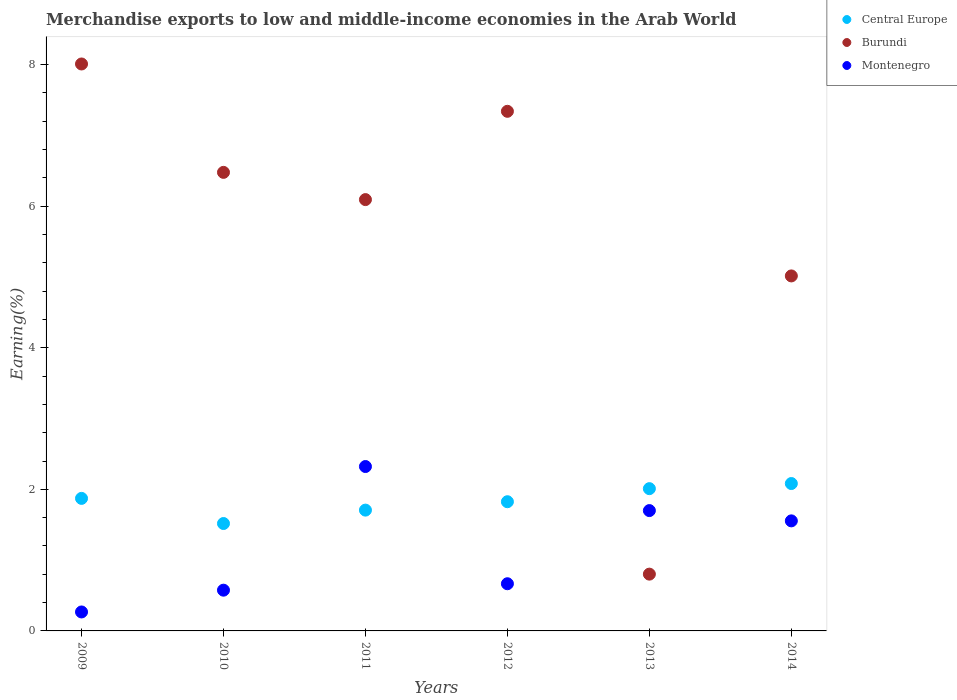How many different coloured dotlines are there?
Provide a succinct answer. 3. Is the number of dotlines equal to the number of legend labels?
Offer a very short reply. Yes. What is the percentage of amount earned from merchandise exports in Central Europe in 2014?
Offer a terse response. 2.08. Across all years, what is the maximum percentage of amount earned from merchandise exports in Central Europe?
Your answer should be very brief. 2.08. Across all years, what is the minimum percentage of amount earned from merchandise exports in Central Europe?
Provide a succinct answer. 1.52. What is the total percentage of amount earned from merchandise exports in Central Europe in the graph?
Give a very brief answer. 11.01. What is the difference between the percentage of amount earned from merchandise exports in Central Europe in 2010 and that in 2011?
Your answer should be very brief. -0.19. What is the difference between the percentage of amount earned from merchandise exports in Burundi in 2014 and the percentage of amount earned from merchandise exports in Central Europe in 2010?
Make the answer very short. 3.5. What is the average percentage of amount earned from merchandise exports in Central Europe per year?
Your answer should be very brief. 1.84. In the year 2014, what is the difference between the percentage of amount earned from merchandise exports in Burundi and percentage of amount earned from merchandise exports in Central Europe?
Your response must be concise. 2.93. In how many years, is the percentage of amount earned from merchandise exports in Central Europe greater than 4 %?
Offer a terse response. 0. What is the ratio of the percentage of amount earned from merchandise exports in Burundi in 2010 to that in 2014?
Offer a very short reply. 1.29. Is the difference between the percentage of amount earned from merchandise exports in Burundi in 2012 and 2014 greater than the difference between the percentage of amount earned from merchandise exports in Central Europe in 2012 and 2014?
Provide a succinct answer. Yes. What is the difference between the highest and the second highest percentage of amount earned from merchandise exports in Central Europe?
Your answer should be very brief. 0.07. What is the difference between the highest and the lowest percentage of amount earned from merchandise exports in Montenegro?
Provide a succinct answer. 2.05. Is the sum of the percentage of amount earned from merchandise exports in Burundi in 2009 and 2012 greater than the maximum percentage of amount earned from merchandise exports in Central Europe across all years?
Offer a very short reply. Yes. Is the percentage of amount earned from merchandise exports in Burundi strictly less than the percentage of amount earned from merchandise exports in Montenegro over the years?
Your answer should be very brief. No. How many dotlines are there?
Give a very brief answer. 3. How many years are there in the graph?
Make the answer very short. 6. Are the values on the major ticks of Y-axis written in scientific E-notation?
Offer a terse response. No. Does the graph contain any zero values?
Provide a succinct answer. No. Where does the legend appear in the graph?
Give a very brief answer. Top right. What is the title of the graph?
Your answer should be very brief. Merchandise exports to low and middle-income economies in the Arab World. What is the label or title of the Y-axis?
Provide a succinct answer. Earning(%). What is the Earning(%) in Central Europe in 2009?
Your answer should be compact. 1.87. What is the Earning(%) in Burundi in 2009?
Make the answer very short. 8.01. What is the Earning(%) of Montenegro in 2009?
Give a very brief answer. 0.27. What is the Earning(%) in Central Europe in 2010?
Your answer should be compact. 1.52. What is the Earning(%) of Burundi in 2010?
Provide a succinct answer. 6.48. What is the Earning(%) of Montenegro in 2010?
Ensure brevity in your answer.  0.58. What is the Earning(%) of Central Europe in 2011?
Offer a very short reply. 1.71. What is the Earning(%) of Burundi in 2011?
Give a very brief answer. 6.09. What is the Earning(%) of Montenegro in 2011?
Your answer should be compact. 2.32. What is the Earning(%) in Central Europe in 2012?
Offer a very short reply. 1.83. What is the Earning(%) of Burundi in 2012?
Provide a succinct answer. 7.34. What is the Earning(%) in Montenegro in 2012?
Ensure brevity in your answer.  0.67. What is the Earning(%) of Central Europe in 2013?
Your answer should be very brief. 2.01. What is the Earning(%) in Burundi in 2013?
Keep it short and to the point. 0.8. What is the Earning(%) in Montenegro in 2013?
Make the answer very short. 1.7. What is the Earning(%) of Central Europe in 2014?
Make the answer very short. 2.08. What is the Earning(%) of Burundi in 2014?
Ensure brevity in your answer.  5.02. What is the Earning(%) of Montenegro in 2014?
Make the answer very short. 1.55. Across all years, what is the maximum Earning(%) in Central Europe?
Your answer should be compact. 2.08. Across all years, what is the maximum Earning(%) in Burundi?
Offer a terse response. 8.01. Across all years, what is the maximum Earning(%) in Montenegro?
Your answer should be very brief. 2.32. Across all years, what is the minimum Earning(%) of Central Europe?
Provide a succinct answer. 1.52. Across all years, what is the minimum Earning(%) in Burundi?
Offer a very short reply. 0.8. Across all years, what is the minimum Earning(%) of Montenegro?
Provide a short and direct response. 0.27. What is the total Earning(%) of Central Europe in the graph?
Provide a short and direct response. 11.01. What is the total Earning(%) in Burundi in the graph?
Your response must be concise. 33.74. What is the total Earning(%) of Montenegro in the graph?
Provide a succinct answer. 7.09. What is the difference between the Earning(%) of Central Europe in 2009 and that in 2010?
Provide a succinct answer. 0.36. What is the difference between the Earning(%) of Burundi in 2009 and that in 2010?
Provide a succinct answer. 1.53. What is the difference between the Earning(%) in Montenegro in 2009 and that in 2010?
Offer a terse response. -0.31. What is the difference between the Earning(%) of Central Europe in 2009 and that in 2011?
Provide a succinct answer. 0.17. What is the difference between the Earning(%) in Burundi in 2009 and that in 2011?
Provide a succinct answer. 1.92. What is the difference between the Earning(%) of Montenegro in 2009 and that in 2011?
Provide a succinct answer. -2.05. What is the difference between the Earning(%) of Central Europe in 2009 and that in 2012?
Offer a very short reply. 0.05. What is the difference between the Earning(%) of Burundi in 2009 and that in 2012?
Your response must be concise. 0.67. What is the difference between the Earning(%) of Montenegro in 2009 and that in 2012?
Your answer should be very brief. -0.4. What is the difference between the Earning(%) in Central Europe in 2009 and that in 2013?
Offer a terse response. -0.14. What is the difference between the Earning(%) in Burundi in 2009 and that in 2013?
Your answer should be compact. 7.21. What is the difference between the Earning(%) in Montenegro in 2009 and that in 2013?
Offer a terse response. -1.43. What is the difference between the Earning(%) in Central Europe in 2009 and that in 2014?
Offer a very short reply. -0.21. What is the difference between the Earning(%) in Burundi in 2009 and that in 2014?
Offer a terse response. 2.99. What is the difference between the Earning(%) in Montenegro in 2009 and that in 2014?
Provide a short and direct response. -1.29. What is the difference between the Earning(%) of Central Europe in 2010 and that in 2011?
Your answer should be compact. -0.19. What is the difference between the Earning(%) of Burundi in 2010 and that in 2011?
Your answer should be compact. 0.38. What is the difference between the Earning(%) of Montenegro in 2010 and that in 2011?
Give a very brief answer. -1.75. What is the difference between the Earning(%) of Central Europe in 2010 and that in 2012?
Give a very brief answer. -0.31. What is the difference between the Earning(%) of Burundi in 2010 and that in 2012?
Offer a terse response. -0.86. What is the difference between the Earning(%) in Montenegro in 2010 and that in 2012?
Your response must be concise. -0.09. What is the difference between the Earning(%) in Central Europe in 2010 and that in 2013?
Make the answer very short. -0.49. What is the difference between the Earning(%) of Burundi in 2010 and that in 2013?
Your answer should be compact. 5.68. What is the difference between the Earning(%) in Montenegro in 2010 and that in 2013?
Offer a very short reply. -1.12. What is the difference between the Earning(%) of Central Europe in 2010 and that in 2014?
Make the answer very short. -0.56. What is the difference between the Earning(%) in Burundi in 2010 and that in 2014?
Provide a short and direct response. 1.46. What is the difference between the Earning(%) of Montenegro in 2010 and that in 2014?
Offer a very short reply. -0.98. What is the difference between the Earning(%) of Central Europe in 2011 and that in 2012?
Make the answer very short. -0.12. What is the difference between the Earning(%) in Burundi in 2011 and that in 2012?
Offer a terse response. -1.25. What is the difference between the Earning(%) in Montenegro in 2011 and that in 2012?
Your answer should be compact. 1.66. What is the difference between the Earning(%) of Central Europe in 2011 and that in 2013?
Make the answer very short. -0.3. What is the difference between the Earning(%) of Burundi in 2011 and that in 2013?
Ensure brevity in your answer.  5.29. What is the difference between the Earning(%) of Montenegro in 2011 and that in 2013?
Make the answer very short. 0.62. What is the difference between the Earning(%) in Central Europe in 2011 and that in 2014?
Offer a terse response. -0.38. What is the difference between the Earning(%) of Burundi in 2011 and that in 2014?
Offer a very short reply. 1.08. What is the difference between the Earning(%) of Montenegro in 2011 and that in 2014?
Keep it short and to the point. 0.77. What is the difference between the Earning(%) of Central Europe in 2012 and that in 2013?
Your answer should be compact. -0.18. What is the difference between the Earning(%) of Burundi in 2012 and that in 2013?
Offer a very short reply. 6.54. What is the difference between the Earning(%) of Montenegro in 2012 and that in 2013?
Offer a very short reply. -1.03. What is the difference between the Earning(%) of Central Europe in 2012 and that in 2014?
Give a very brief answer. -0.26. What is the difference between the Earning(%) in Burundi in 2012 and that in 2014?
Your answer should be compact. 2.33. What is the difference between the Earning(%) in Montenegro in 2012 and that in 2014?
Keep it short and to the point. -0.89. What is the difference between the Earning(%) of Central Europe in 2013 and that in 2014?
Provide a succinct answer. -0.07. What is the difference between the Earning(%) of Burundi in 2013 and that in 2014?
Your answer should be compact. -4.21. What is the difference between the Earning(%) of Montenegro in 2013 and that in 2014?
Provide a succinct answer. 0.15. What is the difference between the Earning(%) of Central Europe in 2009 and the Earning(%) of Burundi in 2010?
Your response must be concise. -4.61. What is the difference between the Earning(%) in Central Europe in 2009 and the Earning(%) in Montenegro in 2010?
Offer a very short reply. 1.3. What is the difference between the Earning(%) in Burundi in 2009 and the Earning(%) in Montenegro in 2010?
Ensure brevity in your answer.  7.43. What is the difference between the Earning(%) of Central Europe in 2009 and the Earning(%) of Burundi in 2011?
Ensure brevity in your answer.  -4.22. What is the difference between the Earning(%) in Central Europe in 2009 and the Earning(%) in Montenegro in 2011?
Provide a succinct answer. -0.45. What is the difference between the Earning(%) of Burundi in 2009 and the Earning(%) of Montenegro in 2011?
Your answer should be compact. 5.69. What is the difference between the Earning(%) in Central Europe in 2009 and the Earning(%) in Burundi in 2012?
Provide a short and direct response. -5.47. What is the difference between the Earning(%) in Central Europe in 2009 and the Earning(%) in Montenegro in 2012?
Your answer should be compact. 1.21. What is the difference between the Earning(%) of Burundi in 2009 and the Earning(%) of Montenegro in 2012?
Ensure brevity in your answer.  7.34. What is the difference between the Earning(%) in Central Europe in 2009 and the Earning(%) in Burundi in 2013?
Ensure brevity in your answer.  1.07. What is the difference between the Earning(%) in Central Europe in 2009 and the Earning(%) in Montenegro in 2013?
Keep it short and to the point. 0.17. What is the difference between the Earning(%) in Burundi in 2009 and the Earning(%) in Montenegro in 2013?
Keep it short and to the point. 6.31. What is the difference between the Earning(%) of Central Europe in 2009 and the Earning(%) of Burundi in 2014?
Make the answer very short. -3.14. What is the difference between the Earning(%) in Central Europe in 2009 and the Earning(%) in Montenegro in 2014?
Provide a succinct answer. 0.32. What is the difference between the Earning(%) in Burundi in 2009 and the Earning(%) in Montenegro in 2014?
Your answer should be compact. 6.45. What is the difference between the Earning(%) in Central Europe in 2010 and the Earning(%) in Burundi in 2011?
Make the answer very short. -4.58. What is the difference between the Earning(%) of Central Europe in 2010 and the Earning(%) of Montenegro in 2011?
Your response must be concise. -0.81. What is the difference between the Earning(%) in Burundi in 2010 and the Earning(%) in Montenegro in 2011?
Offer a very short reply. 4.16. What is the difference between the Earning(%) of Central Europe in 2010 and the Earning(%) of Burundi in 2012?
Your answer should be very brief. -5.82. What is the difference between the Earning(%) of Central Europe in 2010 and the Earning(%) of Montenegro in 2012?
Your answer should be very brief. 0.85. What is the difference between the Earning(%) in Burundi in 2010 and the Earning(%) in Montenegro in 2012?
Keep it short and to the point. 5.81. What is the difference between the Earning(%) in Central Europe in 2010 and the Earning(%) in Burundi in 2013?
Keep it short and to the point. 0.72. What is the difference between the Earning(%) of Central Europe in 2010 and the Earning(%) of Montenegro in 2013?
Ensure brevity in your answer.  -0.18. What is the difference between the Earning(%) in Burundi in 2010 and the Earning(%) in Montenegro in 2013?
Provide a succinct answer. 4.78. What is the difference between the Earning(%) of Central Europe in 2010 and the Earning(%) of Burundi in 2014?
Your answer should be compact. -3.5. What is the difference between the Earning(%) in Central Europe in 2010 and the Earning(%) in Montenegro in 2014?
Your response must be concise. -0.04. What is the difference between the Earning(%) in Burundi in 2010 and the Earning(%) in Montenegro in 2014?
Offer a very short reply. 4.92. What is the difference between the Earning(%) of Central Europe in 2011 and the Earning(%) of Burundi in 2012?
Offer a terse response. -5.63. What is the difference between the Earning(%) of Burundi in 2011 and the Earning(%) of Montenegro in 2012?
Offer a terse response. 5.43. What is the difference between the Earning(%) in Central Europe in 2011 and the Earning(%) in Burundi in 2013?
Offer a very short reply. 0.9. What is the difference between the Earning(%) of Central Europe in 2011 and the Earning(%) of Montenegro in 2013?
Offer a very short reply. 0.01. What is the difference between the Earning(%) in Burundi in 2011 and the Earning(%) in Montenegro in 2013?
Offer a very short reply. 4.39. What is the difference between the Earning(%) in Central Europe in 2011 and the Earning(%) in Burundi in 2014?
Ensure brevity in your answer.  -3.31. What is the difference between the Earning(%) in Central Europe in 2011 and the Earning(%) in Montenegro in 2014?
Make the answer very short. 0.15. What is the difference between the Earning(%) of Burundi in 2011 and the Earning(%) of Montenegro in 2014?
Your answer should be compact. 4.54. What is the difference between the Earning(%) of Central Europe in 2012 and the Earning(%) of Burundi in 2013?
Your answer should be compact. 1.02. What is the difference between the Earning(%) of Central Europe in 2012 and the Earning(%) of Montenegro in 2013?
Give a very brief answer. 0.13. What is the difference between the Earning(%) in Burundi in 2012 and the Earning(%) in Montenegro in 2013?
Ensure brevity in your answer.  5.64. What is the difference between the Earning(%) in Central Europe in 2012 and the Earning(%) in Burundi in 2014?
Offer a terse response. -3.19. What is the difference between the Earning(%) of Central Europe in 2012 and the Earning(%) of Montenegro in 2014?
Your answer should be very brief. 0.27. What is the difference between the Earning(%) of Burundi in 2012 and the Earning(%) of Montenegro in 2014?
Ensure brevity in your answer.  5.79. What is the difference between the Earning(%) in Central Europe in 2013 and the Earning(%) in Burundi in 2014?
Your answer should be compact. -3.01. What is the difference between the Earning(%) in Central Europe in 2013 and the Earning(%) in Montenegro in 2014?
Offer a very short reply. 0.46. What is the difference between the Earning(%) in Burundi in 2013 and the Earning(%) in Montenegro in 2014?
Provide a succinct answer. -0.75. What is the average Earning(%) in Central Europe per year?
Keep it short and to the point. 1.84. What is the average Earning(%) of Burundi per year?
Provide a short and direct response. 5.62. What is the average Earning(%) of Montenegro per year?
Your answer should be compact. 1.18. In the year 2009, what is the difference between the Earning(%) of Central Europe and Earning(%) of Burundi?
Keep it short and to the point. -6.14. In the year 2009, what is the difference between the Earning(%) of Central Europe and Earning(%) of Montenegro?
Your response must be concise. 1.6. In the year 2009, what is the difference between the Earning(%) in Burundi and Earning(%) in Montenegro?
Your response must be concise. 7.74. In the year 2010, what is the difference between the Earning(%) of Central Europe and Earning(%) of Burundi?
Offer a very short reply. -4.96. In the year 2010, what is the difference between the Earning(%) of Central Europe and Earning(%) of Montenegro?
Give a very brief answer. 0.94. In the year 2010, what is the difference between the Earning(%) in Burundi and Earning(%) in Montenegro?
Your response must be concise. 5.9. In the year 2011, what is the difference between the Earning(%) of Central Europe and Earning(%) of Burundi?
Offer a terse response. -4.39. In the year 2011, what is the difference between the Earning(%) of Central Europe and Earning(%) of Montenegro?
Your answer should be very brief. -0.62. In the year 2011, what is the difference between the Earning(%) in Burundi and Earning(%) in Montenegro?
Ensure brevity in your answer.  3.77. In the year 2012, what is the difference between the Earning(%) of Central Europe and Earning(%) of Burundi?
Offer a terse response. -5.52. In the year 2012, what is the difference between the Earning(%) of Central Europe and Earning(%) of Montenegro?
Your answer should be compact. 1.16. In the year 2012, what is the difference between the Earning(%) in Burundi and Earning(%) in Montenegro?
Offer a terse response. 6.67. In the year 2013, what is the difference between the Earning(%) in Central Europe and Earning(%) in Burundi?
Your answer should be very brief. 1.21. In the year 2013, what is the difference between the Earning(%) of Central Europe and Earning(%) of Montenegro?
Make the answer very short. 0.31. In the year 2013, what is the difference between the Earning(%) of Burundi and Earning(%) of Montenegro?
Your answer should be compact. -0.9. In the year 2014, what is the difference between the Earning(%) in Central Europe and Earning(%) in Burundi?
Offer a terse response. -2.93. In the year 2014, what is the difference between the Earning(%) of Central Europe and Earning(%) of Montenegro?
Your answer should be very brief. 0.53. In the year 2014, what is the difference between the Earning(%) in Burundi and Earning(%) in Montenegro?
Provide a short and direct response. 3.46. What is the ratio of the Earning(%) in Central Europe in 2009 to that in 2010?
Keep it short and to the point. 1.23. What is the ratio of the Earning(%) of Burundi in 2009 to that in 2010?
Give a very brief answer. 1.24. What is the ratio of the Earning(%) in Montenegro in 2009 to that in 2010?
Your response must be concise. 0.47. What is the ratio of the Earning(%) of Central Europe in 2009 to that in 2011?
Offer a very short reply. 1.1. What is the ratio of the Earning(%) in Burundi in 2009 to that in 2011?
Offer a very short reply. 1.31. What is the ratio of the Earning(%) of Montenegro in 2009 to that in 2011?
Keep it short and to the point. 0.12. What is the ratio of the Earning(%) of Central Europe in 2009 to that in 2012?
Provide a short and direct response. 1.03. What is the ratio of the Earning(%) in Burundi in 2009 to that in 2012?
Provide a short and direct response. 1.09. What is the ratio of the Earning(%) of Montenegro in 2009 to that in 2012?
Your answer should be compact. 0.4. What is the ratio of the Earning(%) in Central Europe in 2009 to that in 2013?
Make the answer very short. 0.93. What is the ratio of the Earning(%) in Burundi in 2009 to that in 2013?
Your answer should be compact. 9.98. What is the ratio of the Earning(%) in Montenegro in 2009 to that in 2013?
Ensure brevity in your answer.  0.16. What is the ratio of the Earning(%) of Central Europe in 2009 to that in 2014?
Your answer should be very brief. 0.9. What is the ratio of the Earning(%) of Burundi in 2009 to that in 2014?
Give a very brief answer. 1.6. What is the ratio of the Earning(%) in Montenegro in 2009 to that in 2014?
Your response must be concise. 0.17. What is the ratio of the Earning(%) in Central Europe in 2010 to that in 2011?
Your answer should be compact. 0.89. What is the ratio of the Earning(%) in Burundi in 2010 to that in 2011?
Your answer should be very brief. 1.06. What is the ratio of the Earning(%) in Montenegro in 2010 to that in 2011?
Offer a terse response. 0.25. What is the ratio of the Earning(%) in Central Europe in 2010 to that in 2012?
Provide a short and direct response. 0.83. What is the ratio of the Earning(%) of Burundi in 2010 to that in 2012?
Your answer should be compact. 0.88. What is the ratio of the Earning(%) in Montenegro in 2010 to that in 2012?
Offer a terse response. 0.86. What is the ratio of the Earning(%) of Central Europe in 2010 to that in 2013?
Your response must be concise. 0.76. What is the ratio of the Earning(%) in Burundi in 2010 to that in 2013?
Your answer should be compact. 8.08. What is the ratio of the Earning(%) of Montenegro in 2010 to that in 2013?
Your response must be concise. 0.34. What is the ratio of the Earning(%) of Central Europe in 2010 to that in 2014?
Ensure brevity in your answer.  0.73. What is the ratio of the Earning(%) of Burundi in 2010 to that in 2014?
Offer a terse response. 1.29. What is the ratio of the Earning(%) in Montenegro in 2010 to that in 2014?
Offer a terse response. 0.37. What is the ratio of the Earning(%) in Central Europe in 2011 to that in 2012?
Make the answer very short. 0.94. What is the ratio of the Earning(%) of Burundi in 2011 to that in 2012?
Your answer should be very brief. 0.83. What is the ratio of the Earning(%) in Montenegro in 2011 to that in 2012?
Your answer should be compact. 3.48. What is the ratio of the Earning(%) in Central Europe in 2011 to that in 2013?
Make the answer very short. 0.85. What is the ratio of the Earning(%) in Burundi in 2011 to that in 2013?
Make the answer very short. 7.6. What is the ratio of the Earning(%) of Montenegro in 2011 to that in 2013?
Make the answer very short. 1.37. What is the ratio of the Earning(%) of Central Europe in 2011 to that in 2014?
Ensure brevity in your answer.  0.82. What is the ratio of the Earning(%) of Burundi in 2011 to that in 2014?
Provide a succinct answer. 1.22. What is the ratio of the Earning(%) of Montenegro in 2011 to that in 2014?
Your answer should be very brief. 1.49. What is the ratio of the Earning(%) of Central Europe in 2012 to that in 2013?
Provide a short and direct response. 0.91. What is the ratio of the Earning(%) of Burundi in 2012 to that in 2013?
Give a very brief answer. 9.15. What is the ratio of the Earning(%) in Montenegro in 2012 to that in 2013?
Your answer should be compact. 0.39. What is the ratio of the Earning(%) of Central Europe in 2012 to that in 2014?
Offer a terse response. 0.88. What is the ratio of the Earning(%) of Burundi in 2012 to that in 2014?
Provide a succinct answer. 1.46. What is the ratio of the Earning(%) of Montenegro in 2012 to that in 2014?
Give a very brief answer. 0.43. What is the ratio of the Earning(%) of Central Europe in 2013 to that in 2014?
Your response must be concise. 0.97. What is the ratio of the Earning(%) of Burundi in 2013 to that in 2014?
Give a very brief answer. 0.16. What is the ratio of the Earning(%) of Montenegro in 2013 to that in 2014?
Offer a very short reply. 1.09. What is the difference between the highest and the second highest Earning(%) in Central Europe?
Provide a succinct answer. 0.07. What is the difference between the highest and the second highest Earning(%) of Burundi?
Provide a short and direct response. 0.67. What is the difference between the highest and the second highest Earning(%) of Montenegro?
Your answer should be compact. 0.62. What is the difference between the highest and the lowest Earning(%) in Central Europe?
Provide a succinct answer. 0.56. What is the difference between the highest and the lowest Earning(%) of Burundi?
Your answer should be very brief. 7.21. What is the difference between the highest and the lowest Earning(%) of Montenegro?
Give a very brief answer. 2.05. 